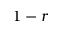Convert formula to latex. <formula><loc_0><loc_0><loc_500><loc_500>1 - r</formula> 